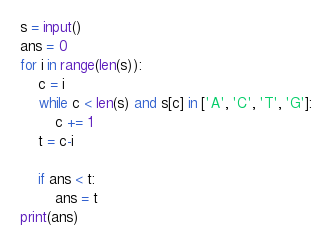<code> <loc_0><loc_0><loc_500><loc_500><_Python_>s = input()
ans = 0
for i in range(len(s)):
    c = i
    while c < len(s) and s[c] in ['A', 'C', 'T', 'G']:
        c += 1
    t = c-i

    if ans < t:
        ans = t
print(ans)
</code> 